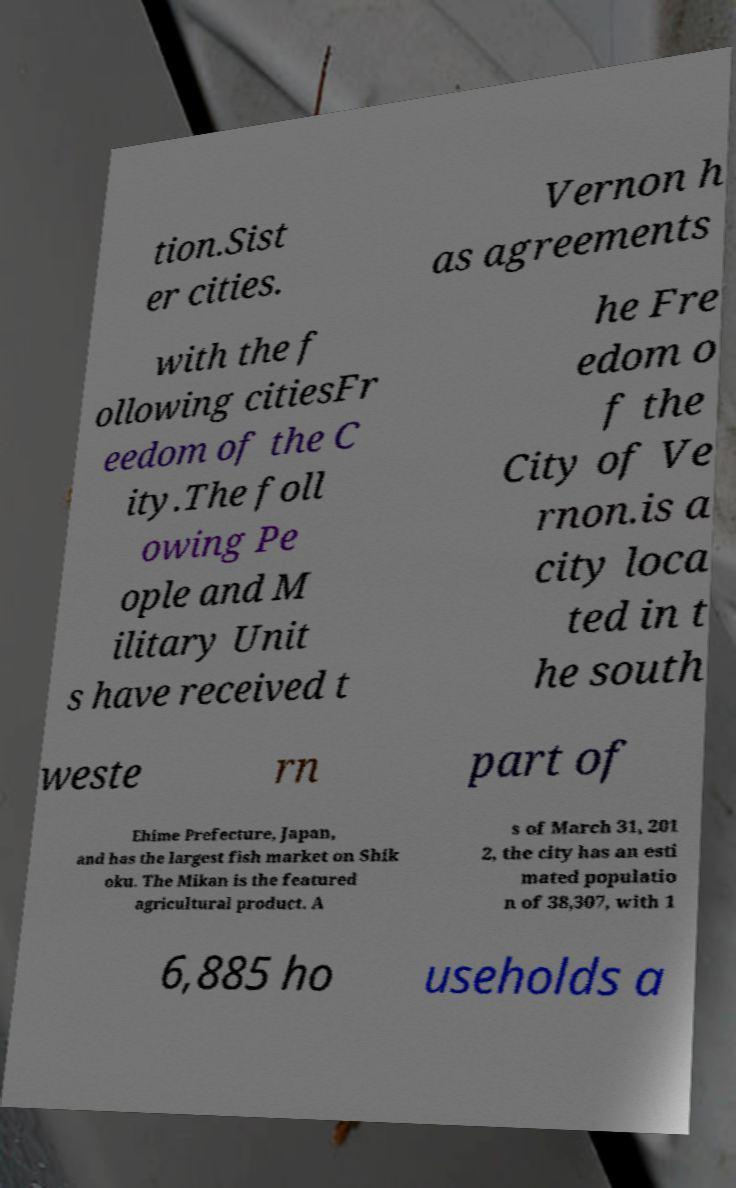Could you extract and type out the text from this image? tion.Sist er cities. Vernon h as agreements with the f ollowing citiesFr eedom of the C ity.The foll owing Pe ople and M ilitary Unit s have received t he Fre edom o f the City of Ve rnon.is a city loca ted in t he south weste rn part of Ehime Prefecture, Japan, and has the largest fish market on Shik oku. The Mikan is the featured agricultural product. A s of March 31, 201 2, the city has an esti mated populatio n of 38,307, with 1 6,885 ho useholds a 